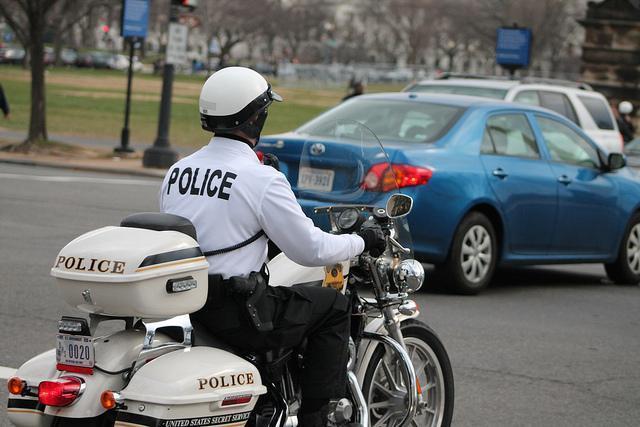How many cars are there?
Give a very brief answer. 2. 